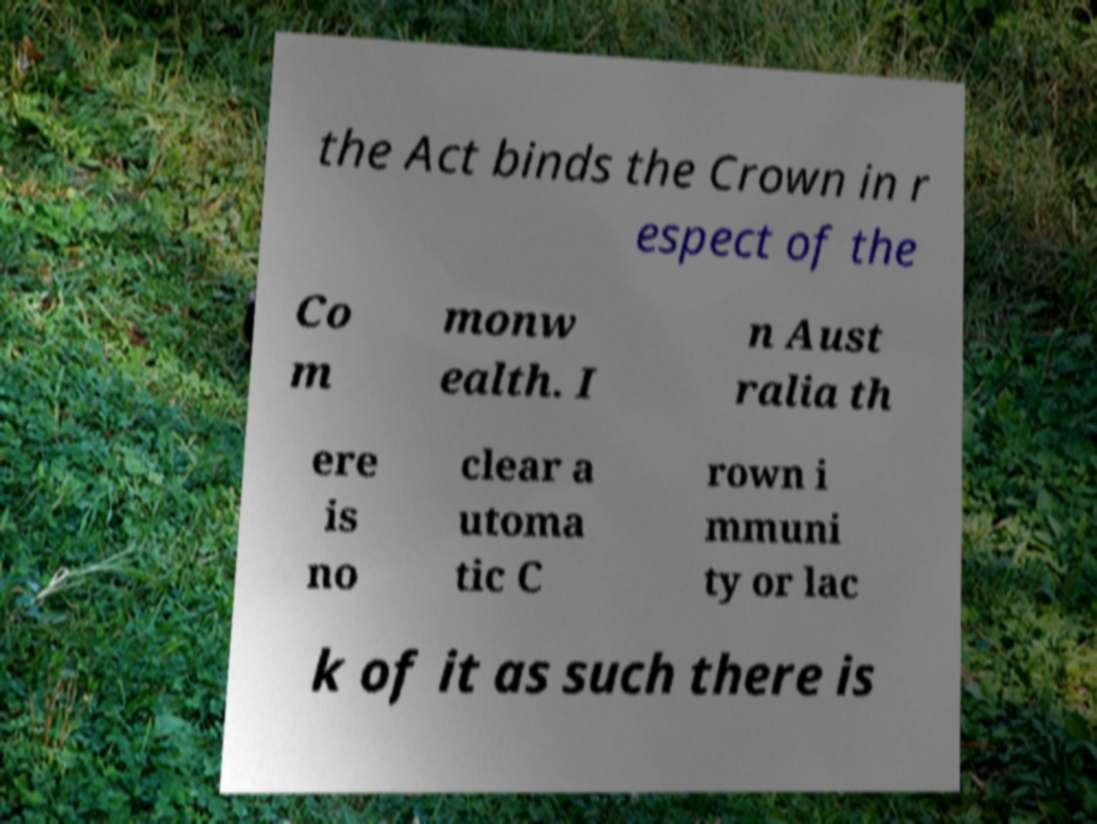Can you read and provide the text displayed in the image?This photo seems to have some interesting text. Can you extract and type it out for me? the Act binds the Crown in r espect of the Co m monw ealth. I n Aust ralia th ere is no clear a utoma tic C rown i mmuni ty or lac k of it as such there is 